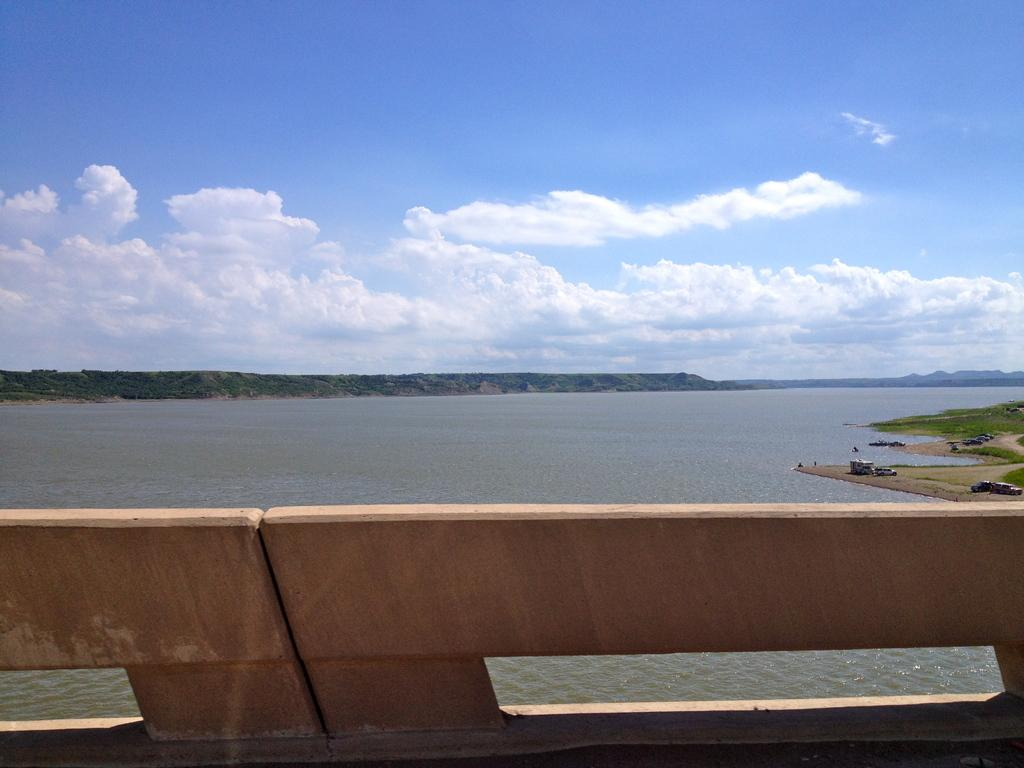What type of barrier is located at the bottom of the image? There is a wooden fence in the bottom of the image. What can be seen in the background of the image? The sky, clouds, a hill, trees, water, vehicles, and grass are visible in the background of the image. Can you describe the sky in the image? The sky is visible in the background of the image. Who is the creator of the amusement park in the image? There is no amusement park present in the image, so it is not possible to determine the creator. How many icicles can be seen hanging from the trees in the image? There are no icicles present in the image; it features a wooden fence, sky, clouds, a hill, trees, water, vehicles, and grass. 